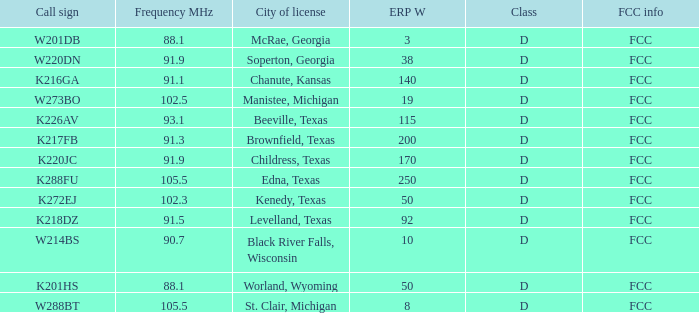What is Call Sign, when ERP W is greater than 50? K216GA, K226AV, K217FB, K220JC, K288FU, K218DZ. 